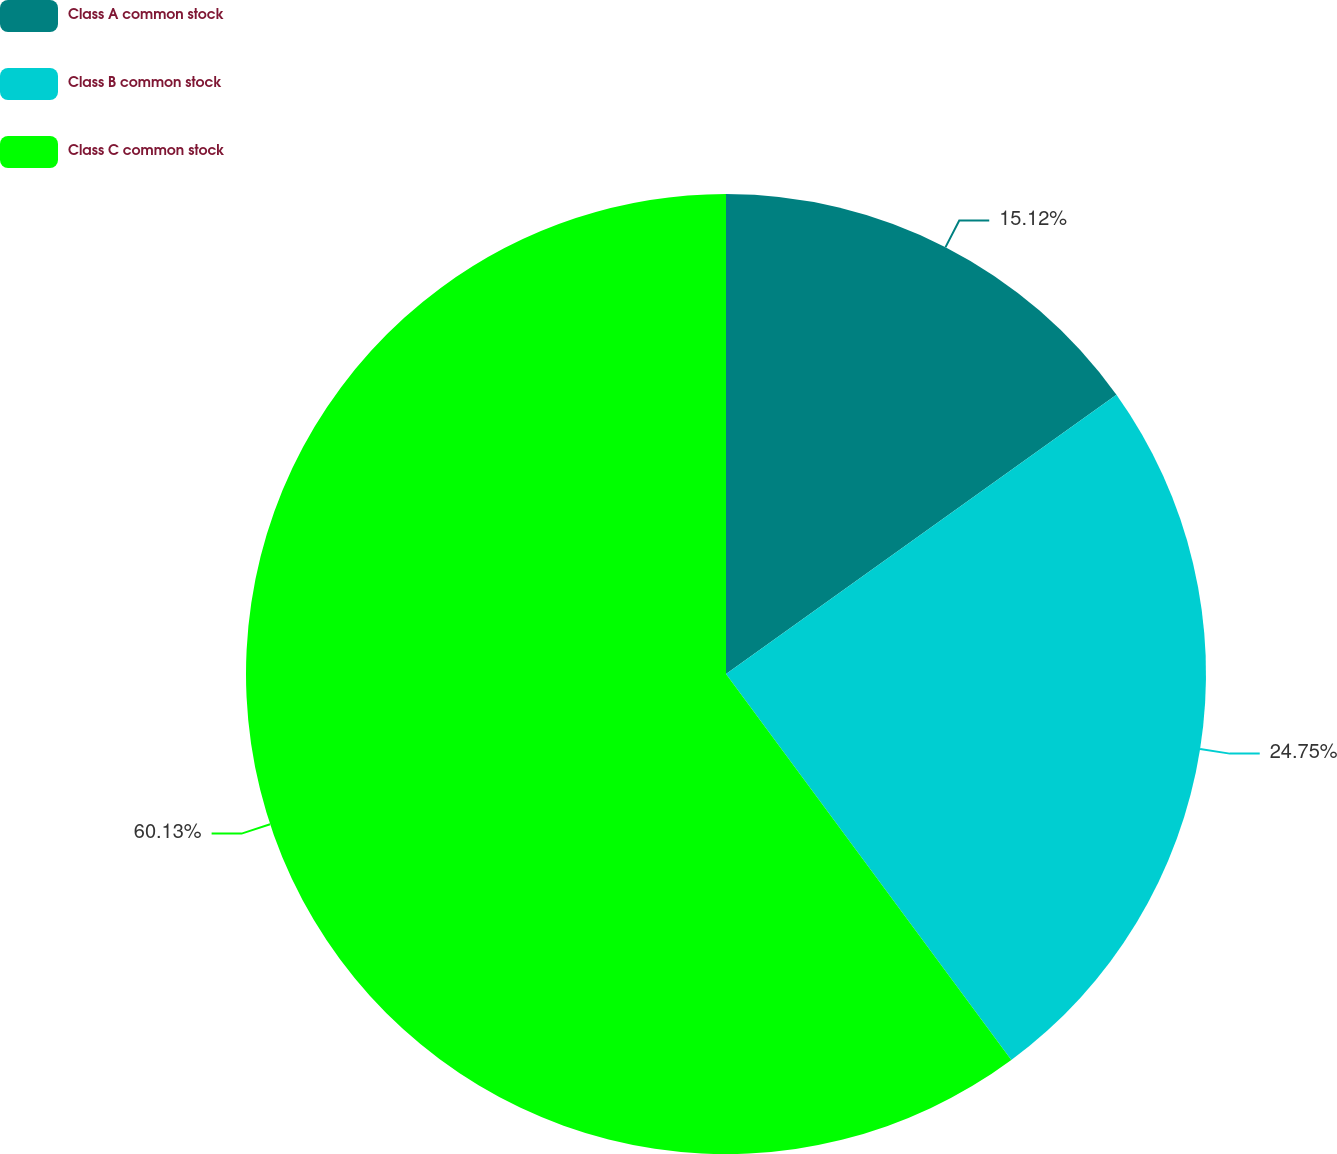Convert chart to OTSL. <chart><loc_0><loc_0><loc_500><loc_500><pie_chart><fcel>Class A common stock<fcel>Class B common stock<fcel>Class C common stock<nl><fcel>15.12%<fcel>24.75%<fcel>60.13%<nl></chart> 